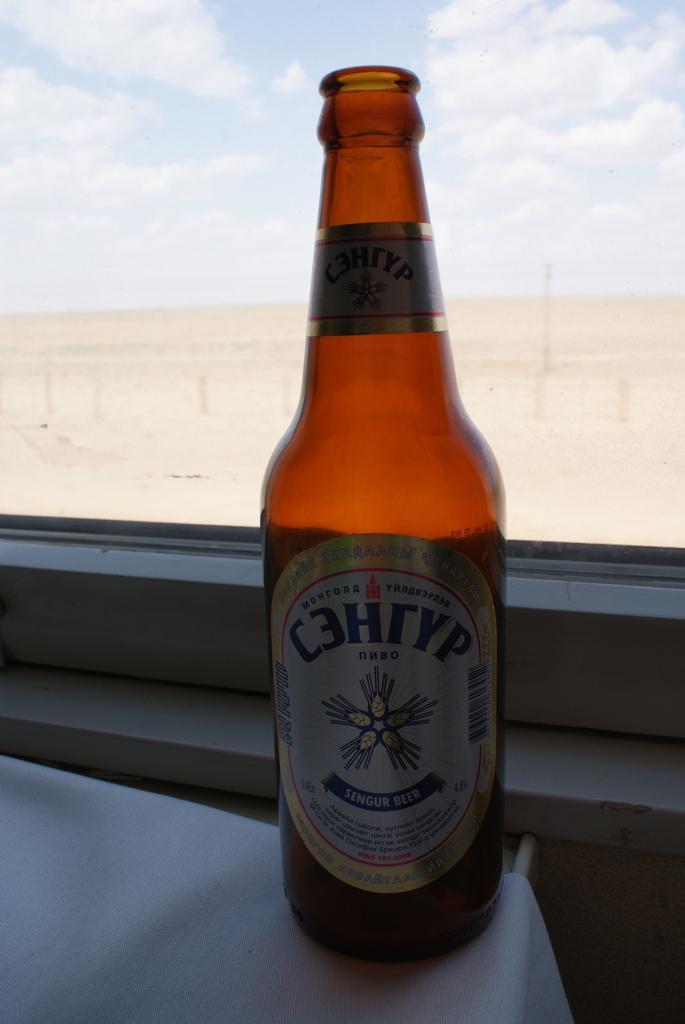How would you summarize this image in a sentence or two? In the picture we can see a table with a white table cloth on it, we can see a wine bottle with a label on it and it is placed near the window with a glass and from it we can see a sand surface and a sky with clouds. 